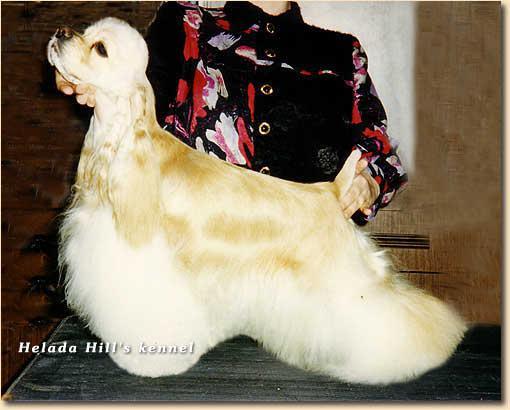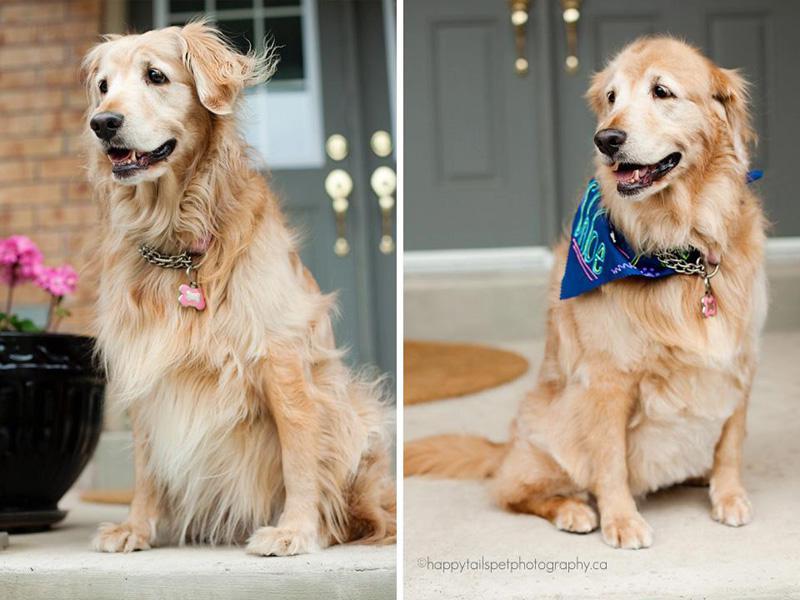The first image is the image on the left, the second image is the image on the right. Evaluate the accuracy of this statement regarding the images: "There is more than one breed of dog in the image.". Is it true? Answer yes or no. Yes. The first image is the image on the left, the second image is the image on the right. Evaluate the accuracy of this statement regarding the images: "Left image shows a person standing behind a left-turned cocker spaniel, holding its chin and tail by a hand.". Is it true? Answer yes or no. Yes. 